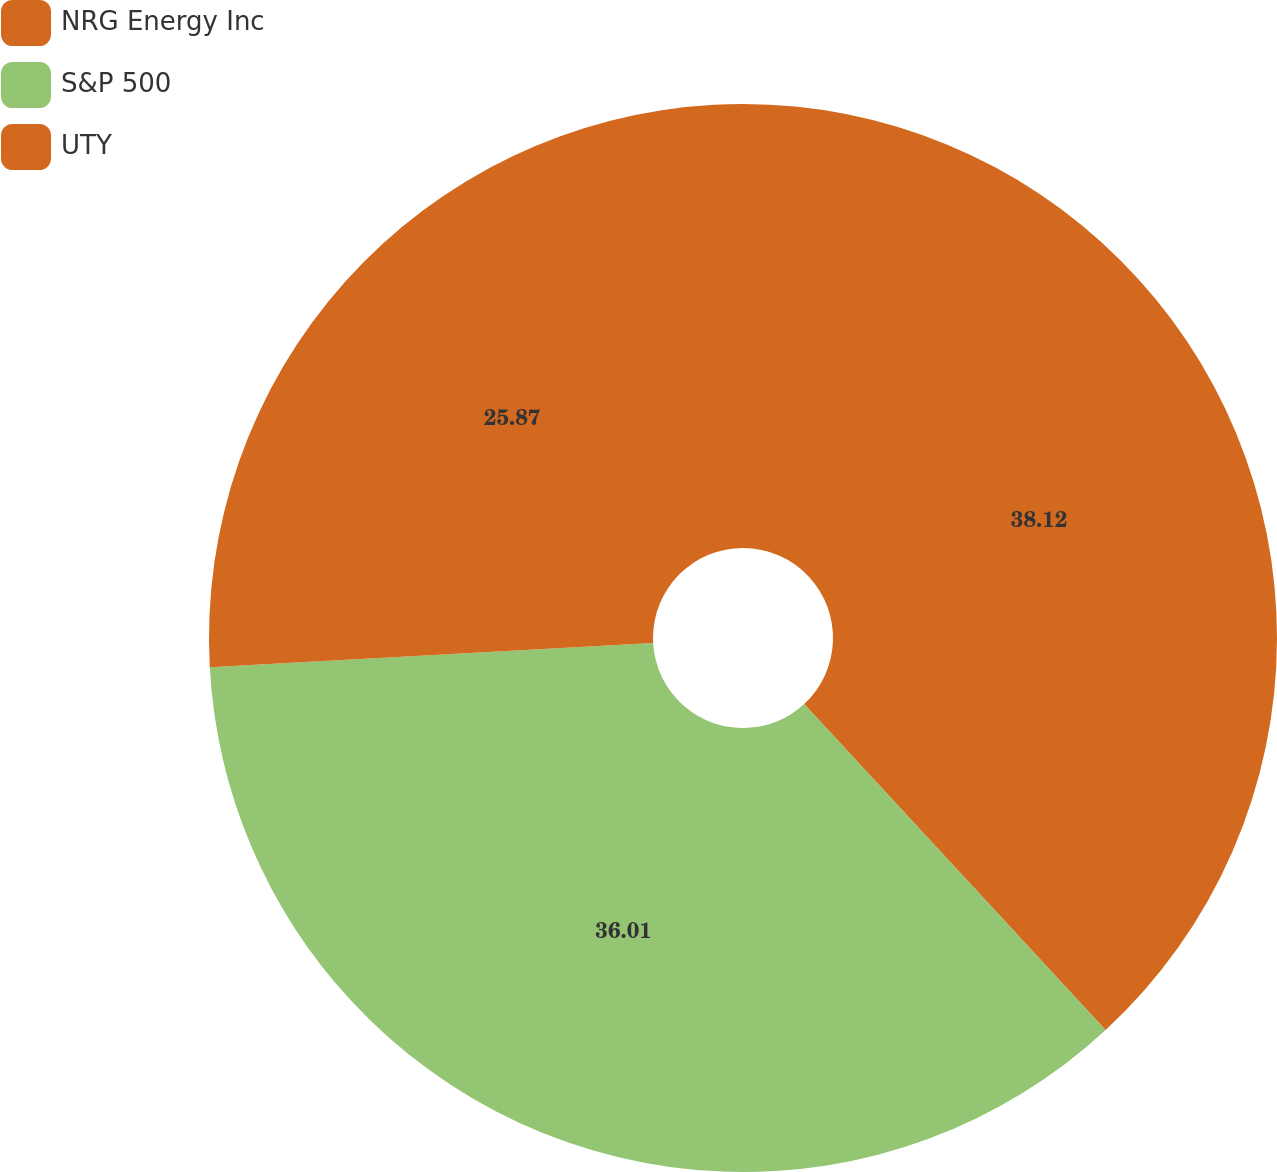Convert chart to OTSL. <chart><loc_0><loc_0><loc_500><loc_500><pie_chart><fcel>NRG Energy Inc<fcel>S&P 500<fcel>UTY<nl><fcel>38.12%<fcel>36.01%<fcel>25.87%<nl></chart> 